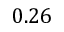Convert formula to latex. <formula><loc_0><loc_0><loc_500><loc_500>0 . 2 6</formula> 